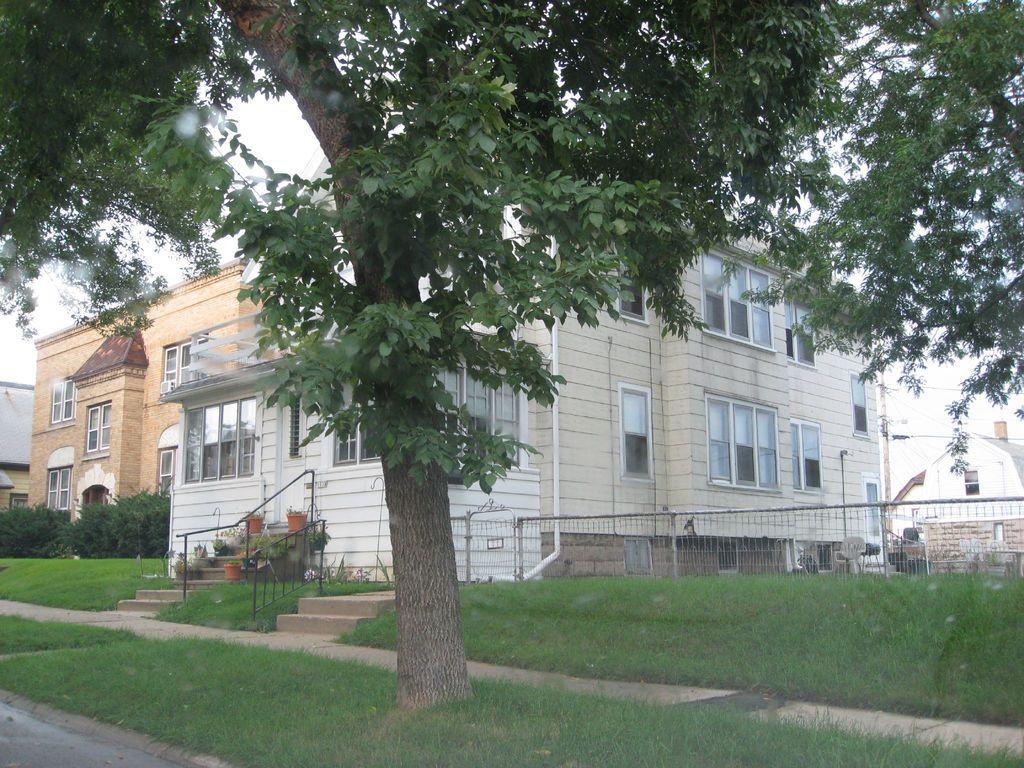How would you summarize this image in a sentence or two? In this picture we can see there are buildings and a tree. On the right side of the image, there is a fence and grass. Behind the tree, there is the sky. 